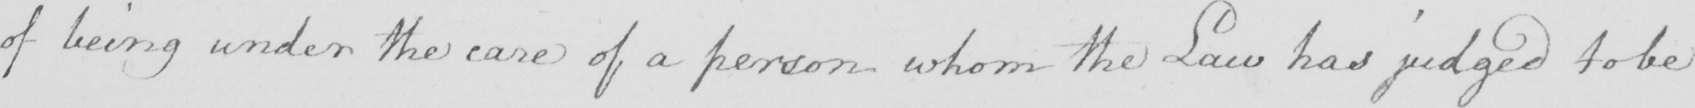Please transcribe the handwritten text in this image. of being under the care of a person whom the Law has judged to be 